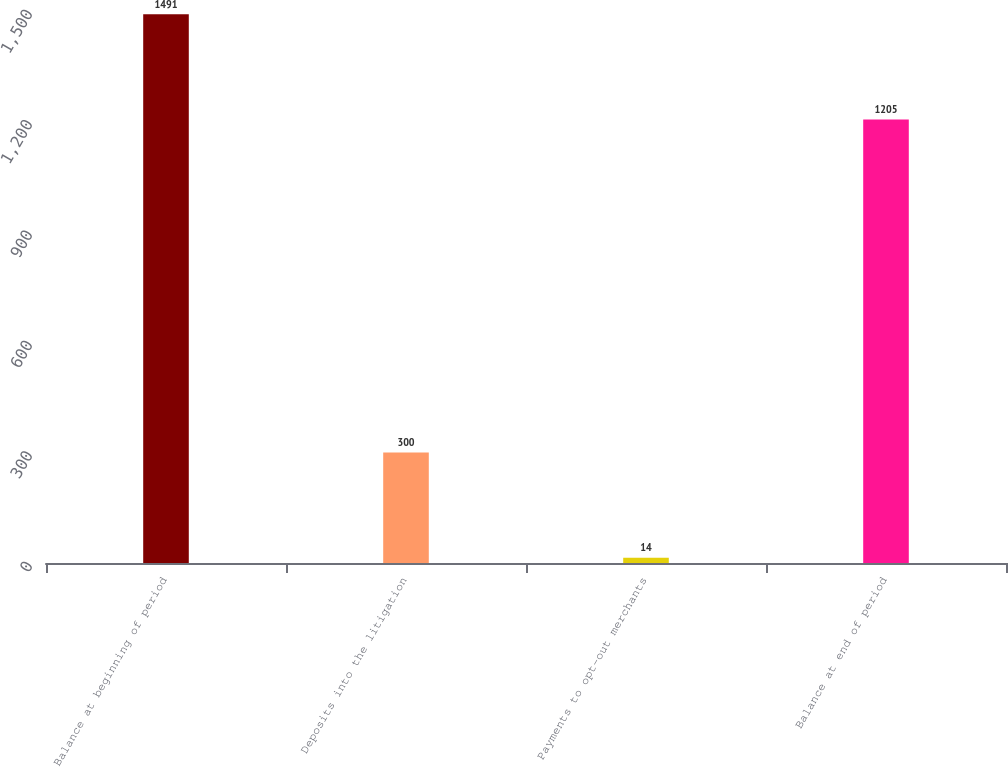Convert chart. <chart><loc_0><loc_0><loc_500><loc_500><bar_chart><fcel>Balance at beginning of period<fcel>Deposits into the litigation<fcel>Payments to opt-out merchants<fcel>Balance at end of period<nl><fcel>1491<fcel>300<fcel>14<fcel>1205<nl></chart> 